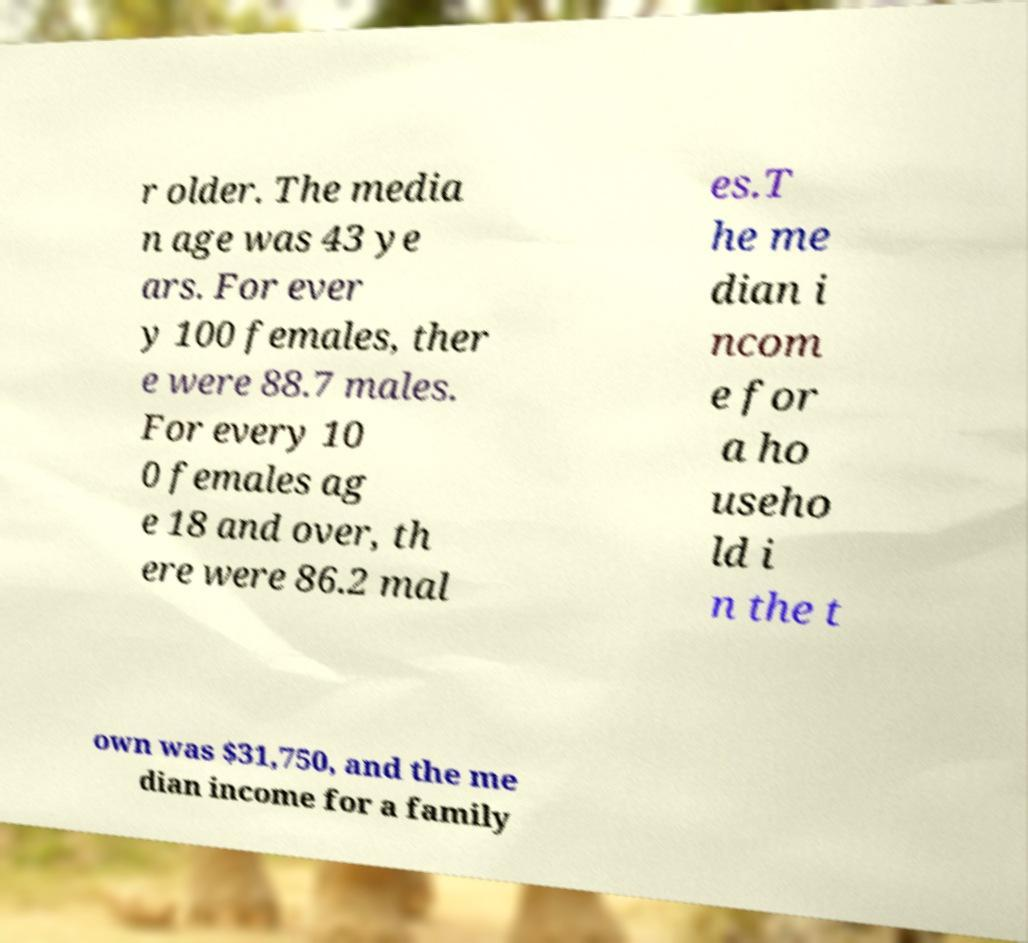For documentation purposes, I need the text within this image transcribed. Could you provide that? r older. The media n age was 43 ye ars. For ever y 100 females, ther e were 88.7 males. For every 10 0 females ag e 18 and over, th ere were 86.2 mal es.T he me dian i ncom e for a ho useho ld i n the t own was $31,750, and the me dian income for a family 